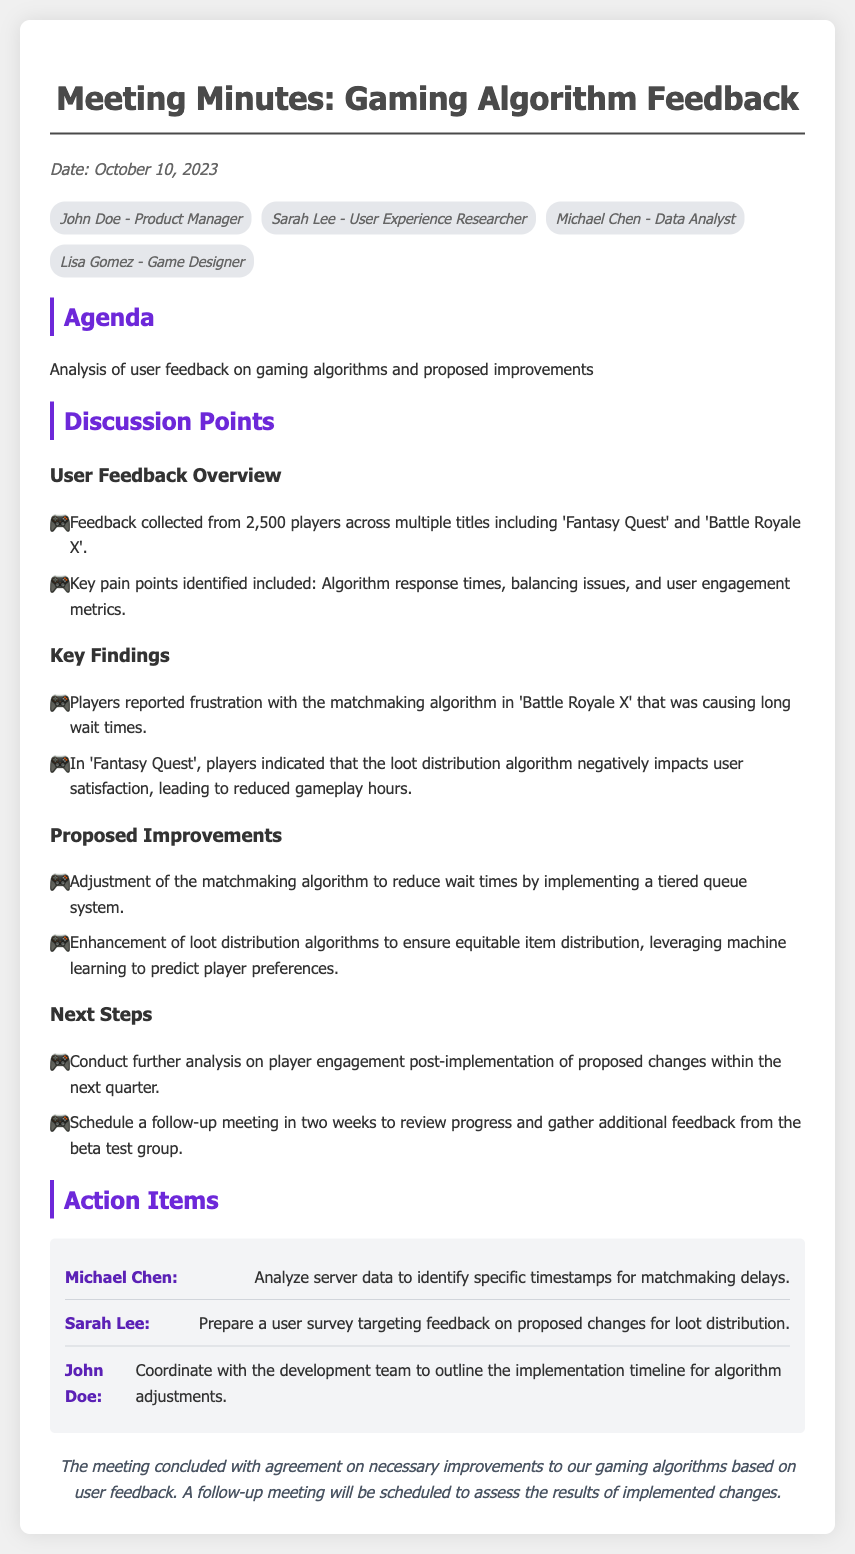What date was the meeting held? The date of the meeting is mentioned at the beginning of the document.
Answer: October 10, 2023 Who is responsible for analyzing server data? The action item clearly states which attendee is responsible for this task.
Answer: Michael Chen What were the key pain points identified? The pain points are outlined in the User Feedback Overview section.
Answer: Algorithm response times, balancing issues, and user engagement metrics How many players provided feedback? The total number of players from whom feedback was collected is specified in the User Feedback Overview.
Answer: 2,500 players What type of algorithm adjustment is proposed for matchmaking? The proposed improvement for matchmaking is detailed in the proposed improvements section.
Answer: Tiered queue system Who is tasked with preparing a user survey? The responsible person for the user survey is specified in the action items section.
Answer: Sarah Lee How many discussion points are listed? The number of discussion subheadings indicates the points addressed in the meeting.
Answer: Three points What is the follow-up timeline mentioned? The timing for the follow-up meeting is mentioned in the Next Steps section.
Answer: In two weeks 